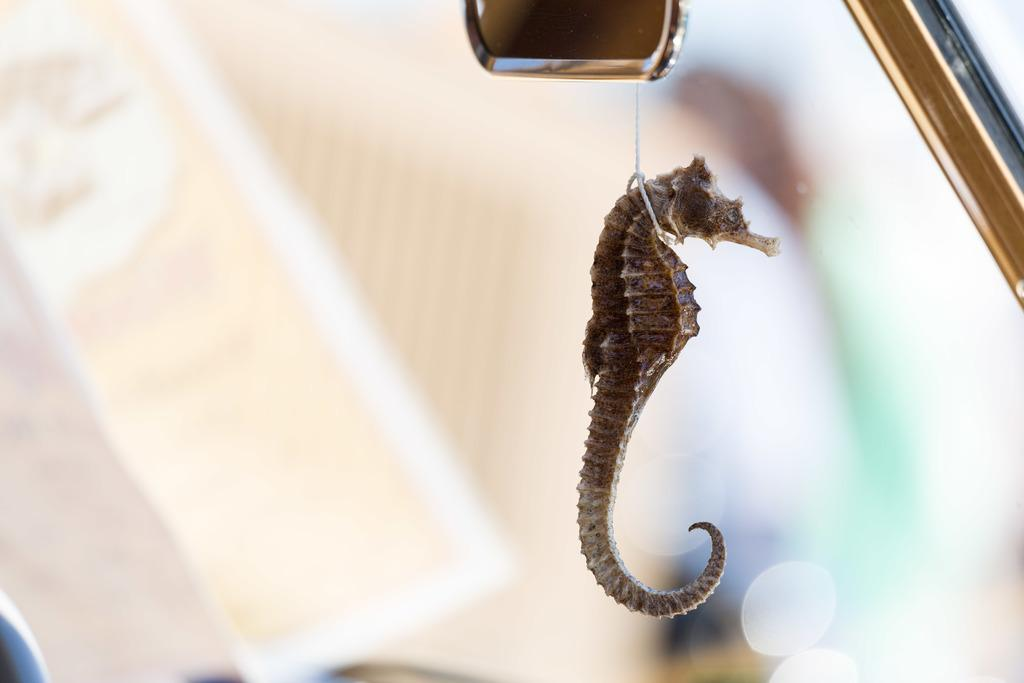What type of toy is present in the image? There is a toy in the image, specifically a water horse. Where is the water horse located in the image? The water horse is hanged in a vehicle. What other object can be seen in the image? There is a mirror in the image. How would you describe the background of the image? The background of the image is blurry. What is the weather like in the image? The provided facts do not mention anything about the weather, so it cannot be determined from the image. 